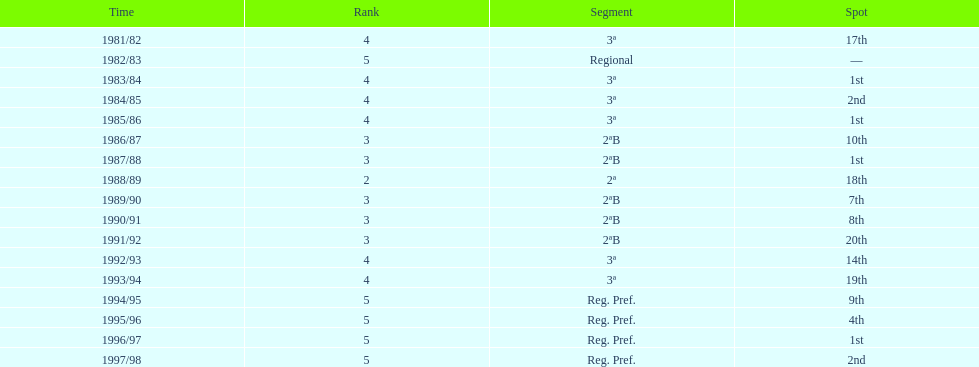Which tier was ud alzira a part of the least? 2. 